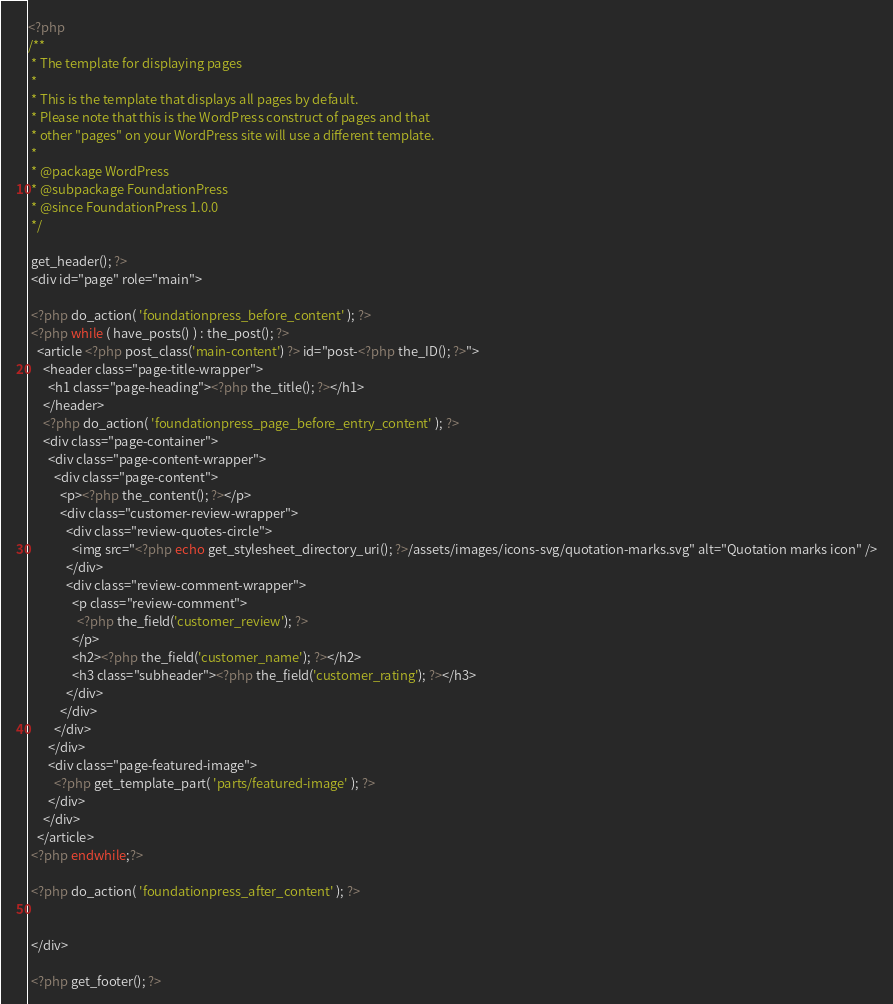<code> <loc_0><loc_0><loc_500><loc_500><_PHP_><?php
/**
 * The template for displaying pages
 *
 * This is the template that displays all pages by default.
 * Please note that this is the WordPress construct of pages and that
 * other "pages" on your WordPress site will use a different template.
 *
 * @package WordPress
 * @subpackage FoundationPress
 * @since FoundationPress 1.0.0
 */

 get_header(); ?>
 <div id="page" role="main">

 <?php do_action( 'foundationpress_before_content' ); ?>
 <?php while ( have_posts() ) : the_post(); ?>
   <article <?php post_class('main-content') ?> id="post-<?php the_ID(); ?>">
     <header class="page-title-wrapper">
       <h1 class="page-heading"><?php the_title(); ?></h1>
   	 </header>
     <?php do_action( 'foundationpress_page_before_entry_content' ); ?>
     <div class="page-container">
       <div class="page-content-wrapper">
         <div class="page-content">
           <p><?php the_content(); ?></p>
           <div class="customer-review-wrapper">
             <div class="review-quotes-circle">
               <img src="<?php echo get_stylesheet_directory_uri(); ?>/assets/images/icons-svg/quotation-marks.svg" alt="Quotation marks icon" />
             </div>
             <div class="review-comment-wrapper">
               <p class="review-comment">
                 <?php the_field('customer_review'); ?>
               </p>
               <h2><?php the_field('customer_name'); ?></h2>
               <h3 class="subheader"><?php the_field('customer_rating'); ?></h3>
             </div>
           </div>
         </div>
       </div>
       <div class="page-featured-image">
         <?php get_template_part( 'parts/featured-image' ); ?>
       </div>
     </div>
   </article>
 <?php endwhile;?>

 <?php do_action( 'foundationpress_after_content' ); ?>


 </div>

 <?php get_footer(); ?>
</code> 